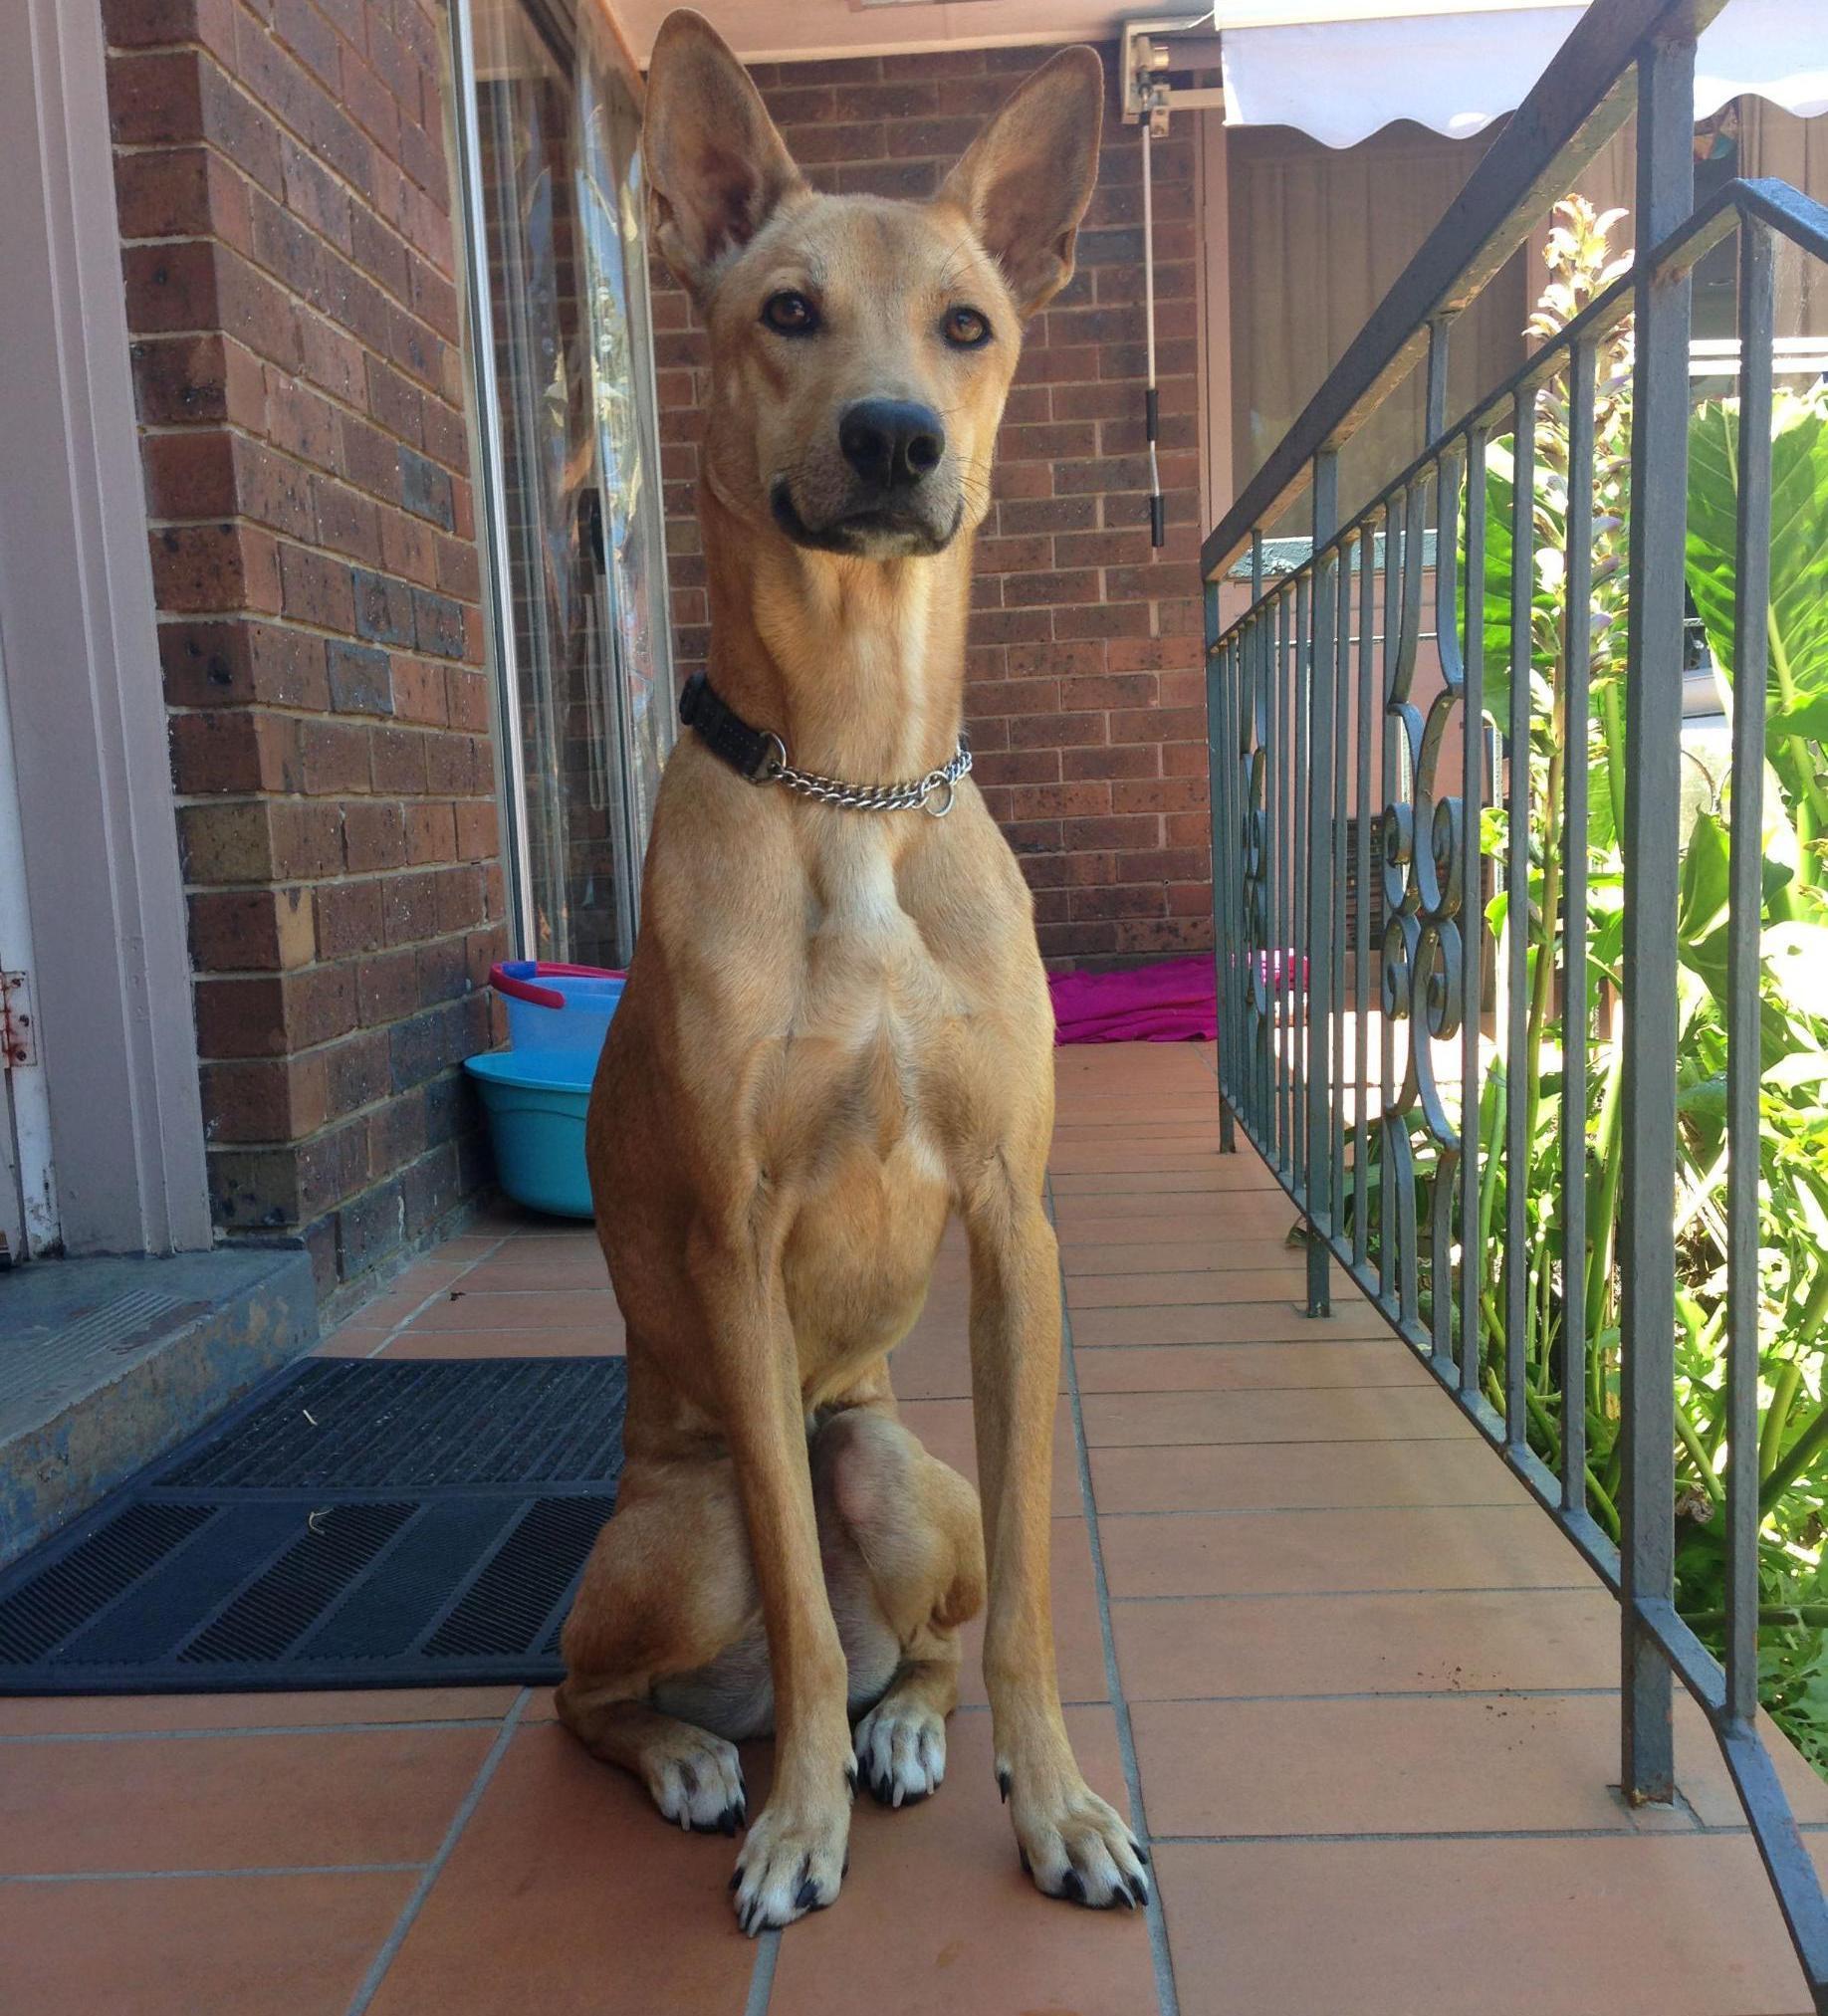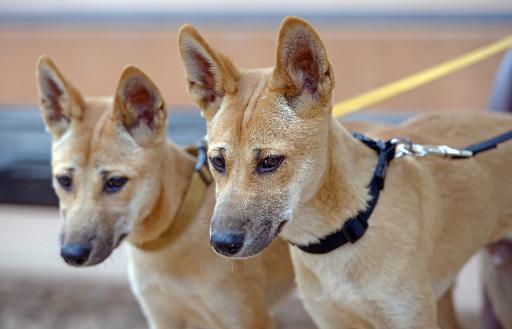The first image is the image on the left, the second image is the image on the right. Considering the images on both sides, is "At least one dog is not wearing a collar." valid? Answer yes or no. No. 